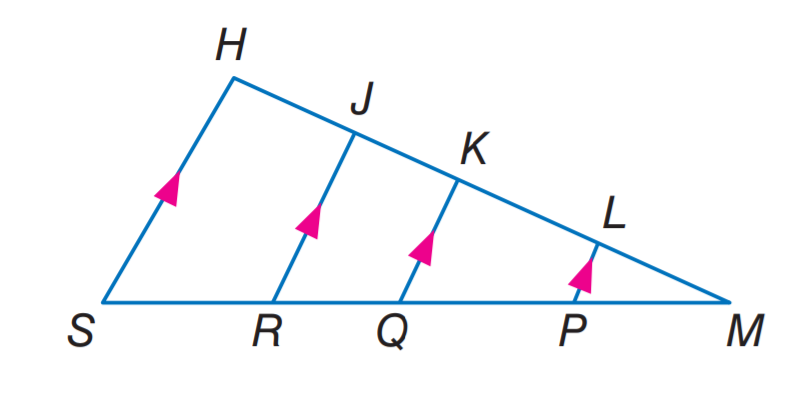Answer the mathemtical geometry problem and directly provide the correct option letter.
Question: If L K = 4, M P = 3, P Q = 6, K J = 2, R S = 6, and L P = 2, find Q K.
Choices: A: 2 B: 3 C: 4 D: 6 D 